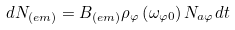<formula> <loc_0><loc_0><loc_500><loc_500>d N _ { \left ( e m \right ) } = B _ { ( e m ) } \rho _ { \varphi } \left ( \omega _ { \varphi 0 } \right ) N _ { a \varphi } d t</formula> 